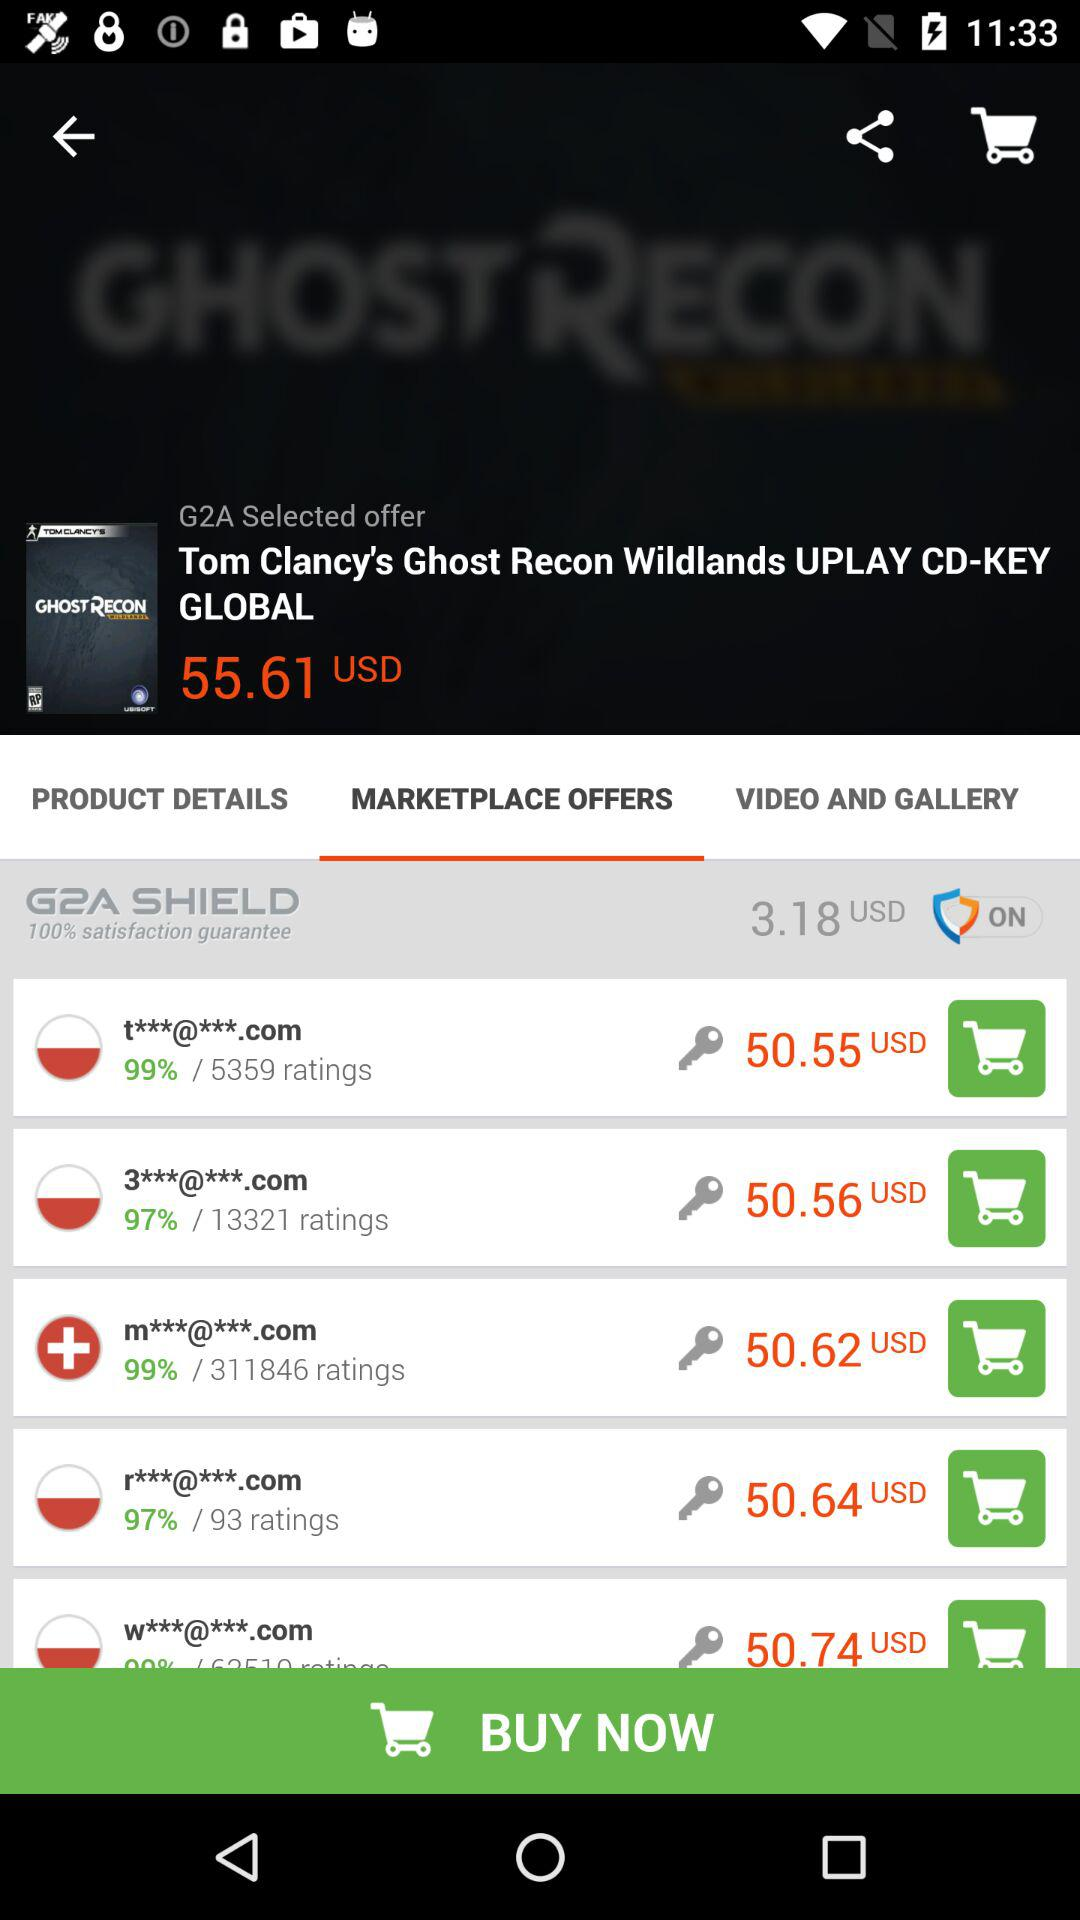What is the price of the "Tom Clancy's Ghost Recon Wildlands UPLAY CD-KEY GLOBAL"? The price of the "Tom Clancy's Ghost Recon Wildlands UPLAY CD-KEY GLOBAL" is 55.61 USD. 